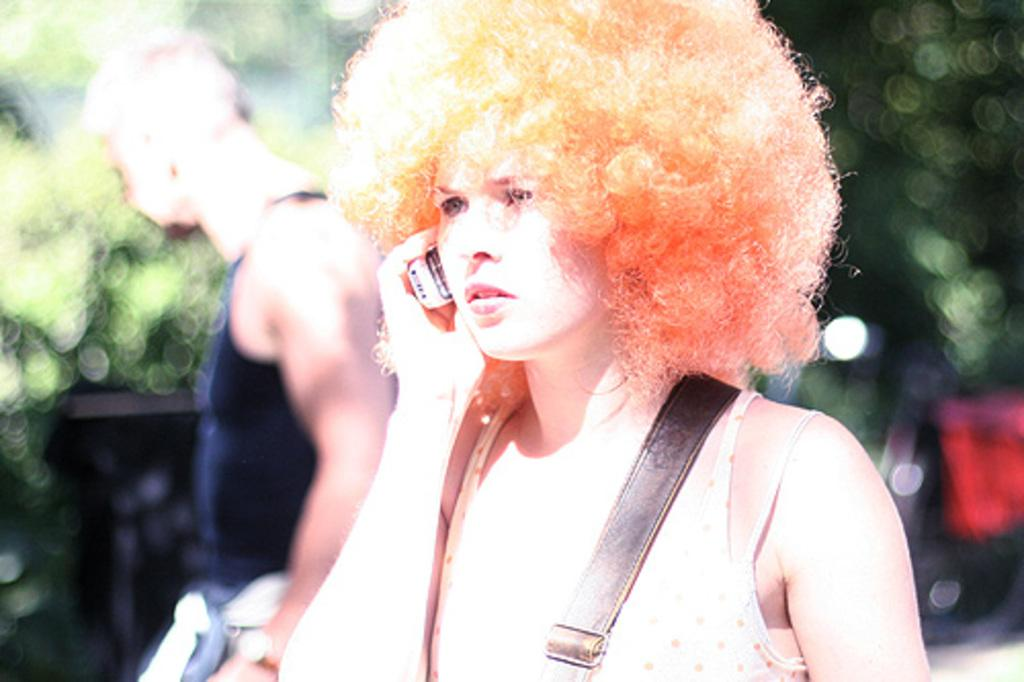How many people are in the image? There are persons in the image, but the exact number is not specified. What are the persons wearing? The persons are wearing clothes. Can you describe the background of the image? The background of the image is blurred. What type of toothpaste is being used by the person in the image? There is no toothpaste present in the image, as the focus is on the persons and their clothing. Can you identify any plants in the image? There is no mention of plants in the image, so we cannot determine if any are present. 